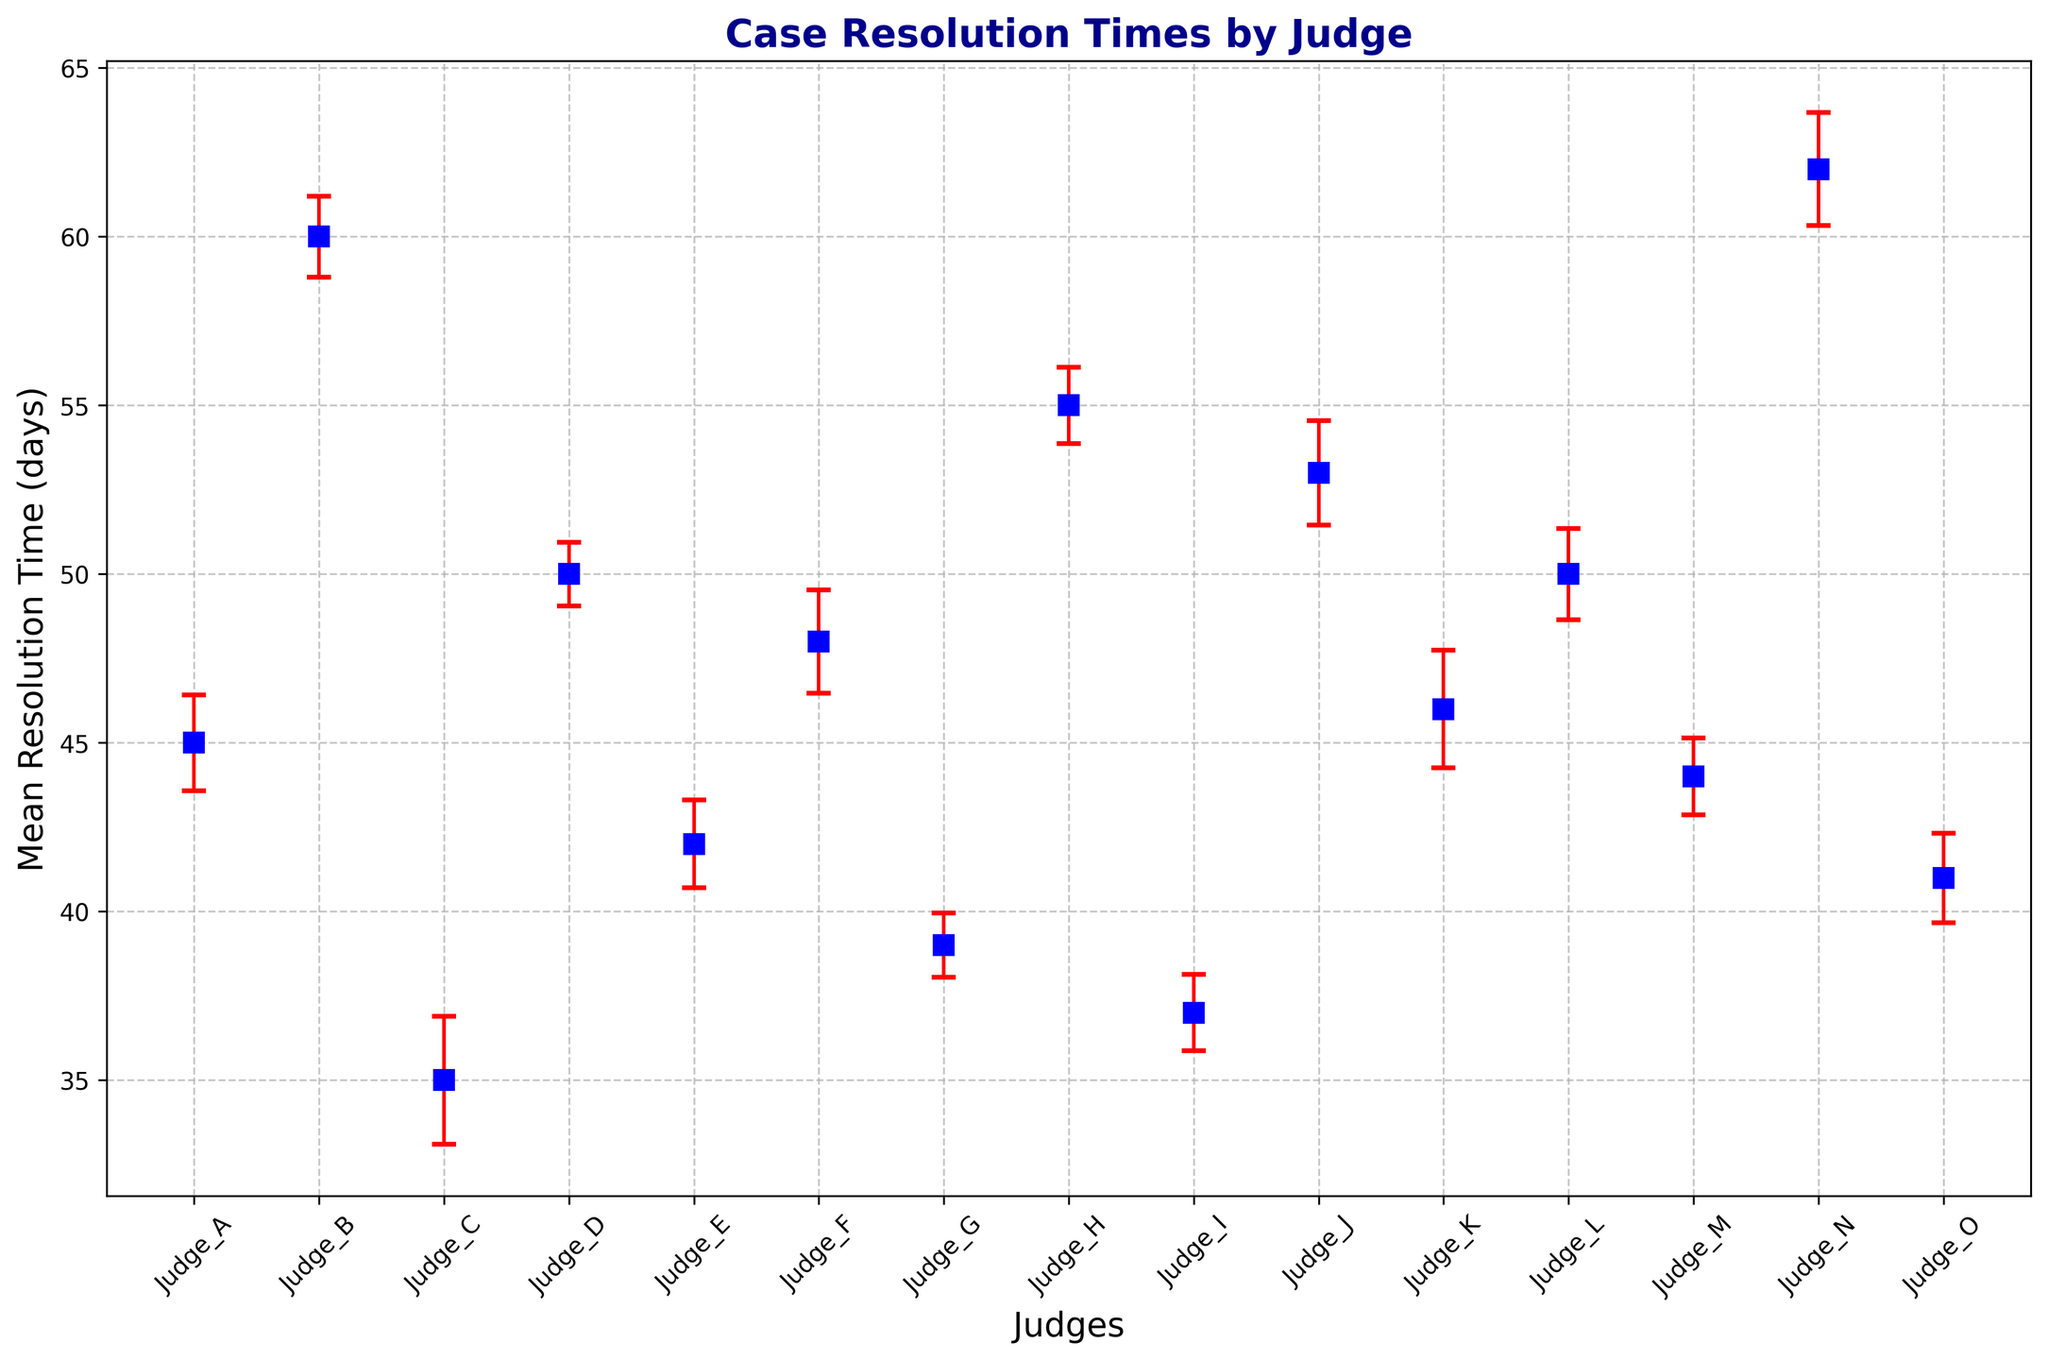What's the average mean resolution time across all judges? We sum up the mean resolution times for all judges: (45 + 60 + 35 + 50 + 42 + 48 + 39 + 55 + 37 + 53 + 46 + 50 + 44 + 62 + 41) = 707. Divide this sum by the number of judges (15) to get 707 / 15 ≈ 47.13.
Answer: 47.13 days Which judge has the longest mean resolution time? By observing the plot, we can see that the judge with the highest point on the y-axis represents the longest mean resolution time. This corresponds to Judge N with a mean resolution time of 62 days.
Answer: Judge N Which judge has the shortest mean resolution time? By examining the figure, the judge with the lowest point on the y-axis represents the shortest mean resolution time. This is Judge C with a mean resolution time of 35 days.
Answer: Judge C What's the difference in mean resolution time between Judge B and Judge G? The mean resolution time for Judge B is 60 days, and for Judge G, it is 39 days. The difference is calculated as 60 - 39 = 21 days.
Answer: 21 days Which judge shows the highest variability in their resolution times? Variability is indicated by the error bars. The judge with the longest error bars has the highest variability. In this case, Judge C and Judge K have the highest variability, as indicated by similar large error bars.
Answer: Judge C and Judge K Between Judge J and Judge L, who has more consistent resolution times based on variability? Consistency is indicated by smaller error bars. Judge L has smaller (shorter) error bars compared to Judge J, indicating more consistent resolution times.
Answer: Judge L Which judge's mean resolution time is closest to the average mean resolution time of all judges? The average mean resolution time is 47.13 days. By comparing individual mean resolution times, Judge F with 48 days is the closest.
Answer: Judge F How many judges have a mean resolution time greater than 50 days? From the plot, the judges with mean resolution times greater than 50 days are Judge B, Judge D, Judge H, Judge J, and Judge N. Therefore, there are 5 judges.
Answer: 5 judges Is there any judge whose error margin (standard error) exceeds 2 days? If yes, name them. The standard error is the standard deviation divided by the square root of the sample size. Calculate each judge's standard error and check if it exceeds 2. Several judges have error margins exceeding 2 days, including Judge A, Judge C, Judge F, and Judge K.
Answer: Judge A, Judge C, Judge F, Judge K 